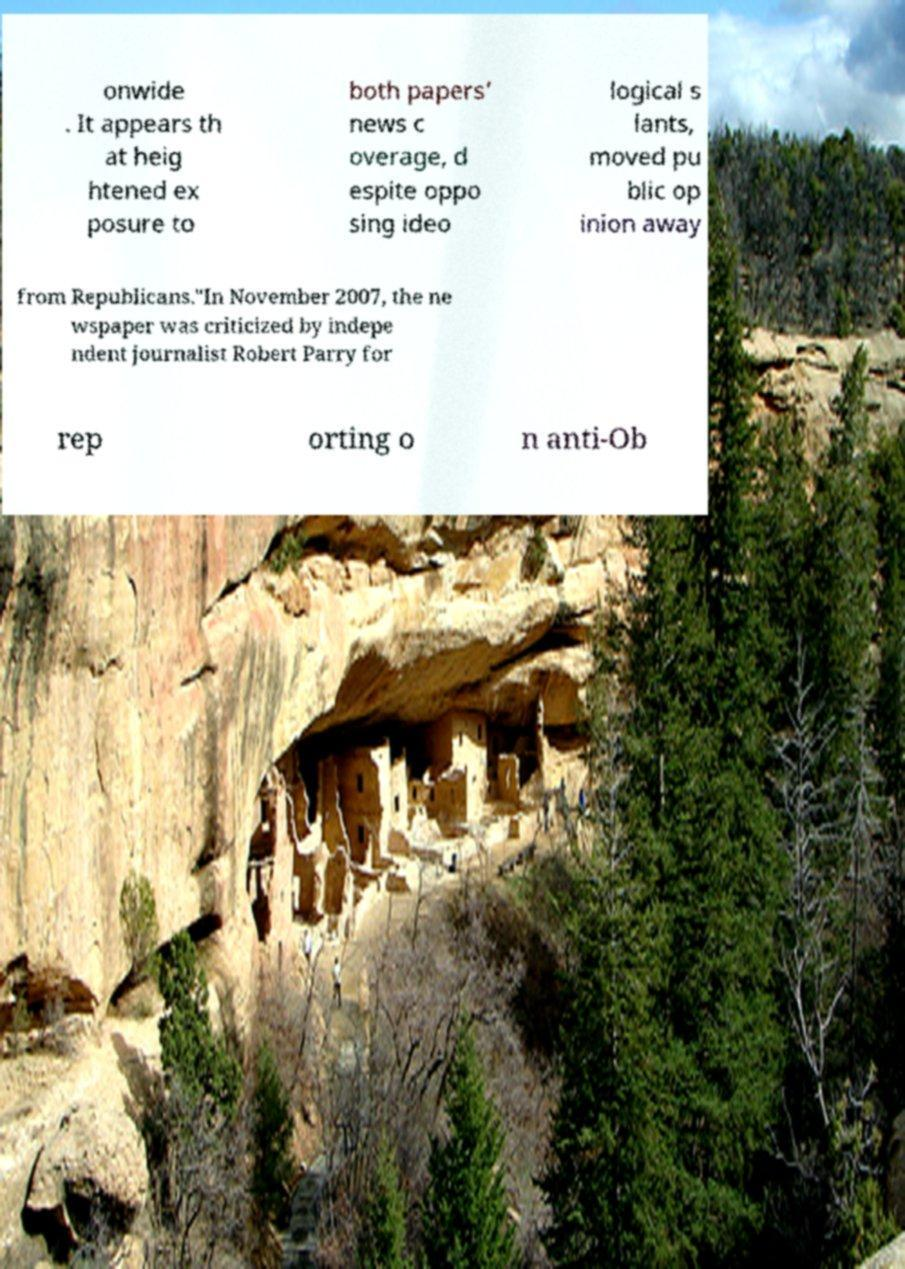Could you extract and type out the text from this image? onwide . It appears th at heig htened ex posure to both papers’ news c overage, d espite oppo sing ideo logical s lants, moved pu blic op inion away from Republicans."In November 2007, the ne wspaper was criticized by indepe ndent journalist Robert Parry for rep orting o n anti-Ob 